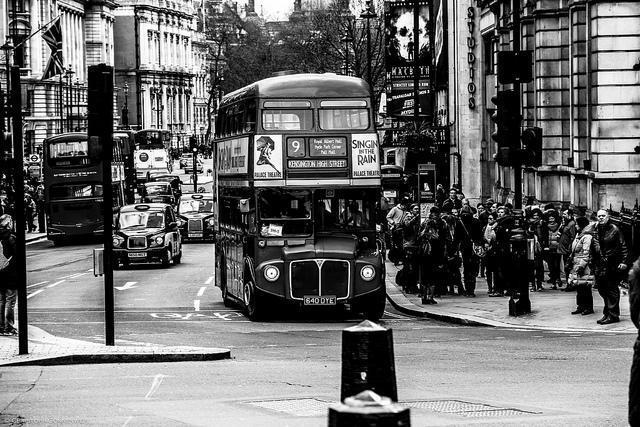How many people can you see?
Give a very brief answer. 2. How many traffic lights are visible?
Give a very brief answer. 2. How many buses are there?
Give a very brief answer. 2. How many horses are pictured?
Give a very brief answer. 0. 